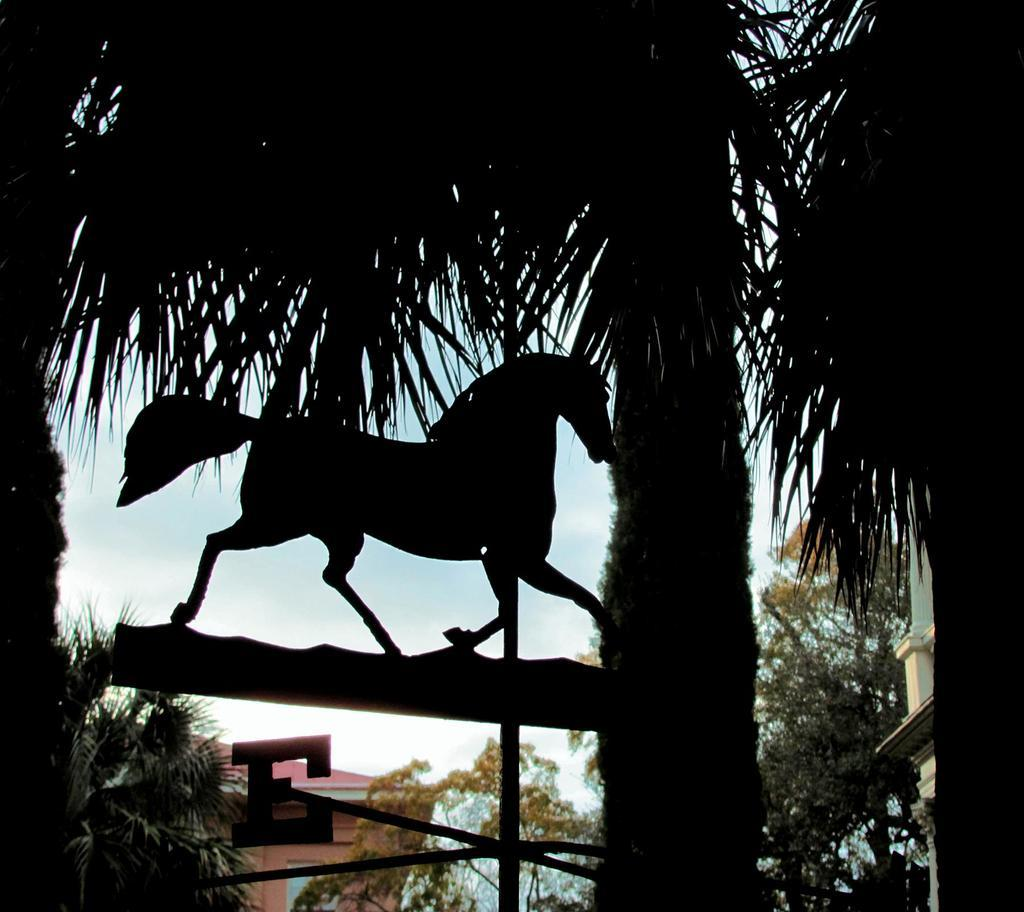What type of vegetation can be seen in the image? There are trees in the image. What kind of sculpture is present in the image? There is a sculpture of a horse in the image. What is visible in the background of the image? The sky is visible in the image. Can you identify any man-made structures in the image? There appears to be a house in the image. What event is taking place in front of the house in the image? There is no event visible in the image; it only shows trees, a sculpture of a horse, the sky, and a house. Can you see the moon in the image? The image does not show the moon; it only shows the sky, which is not detailed enough to determine if the moon is present. 